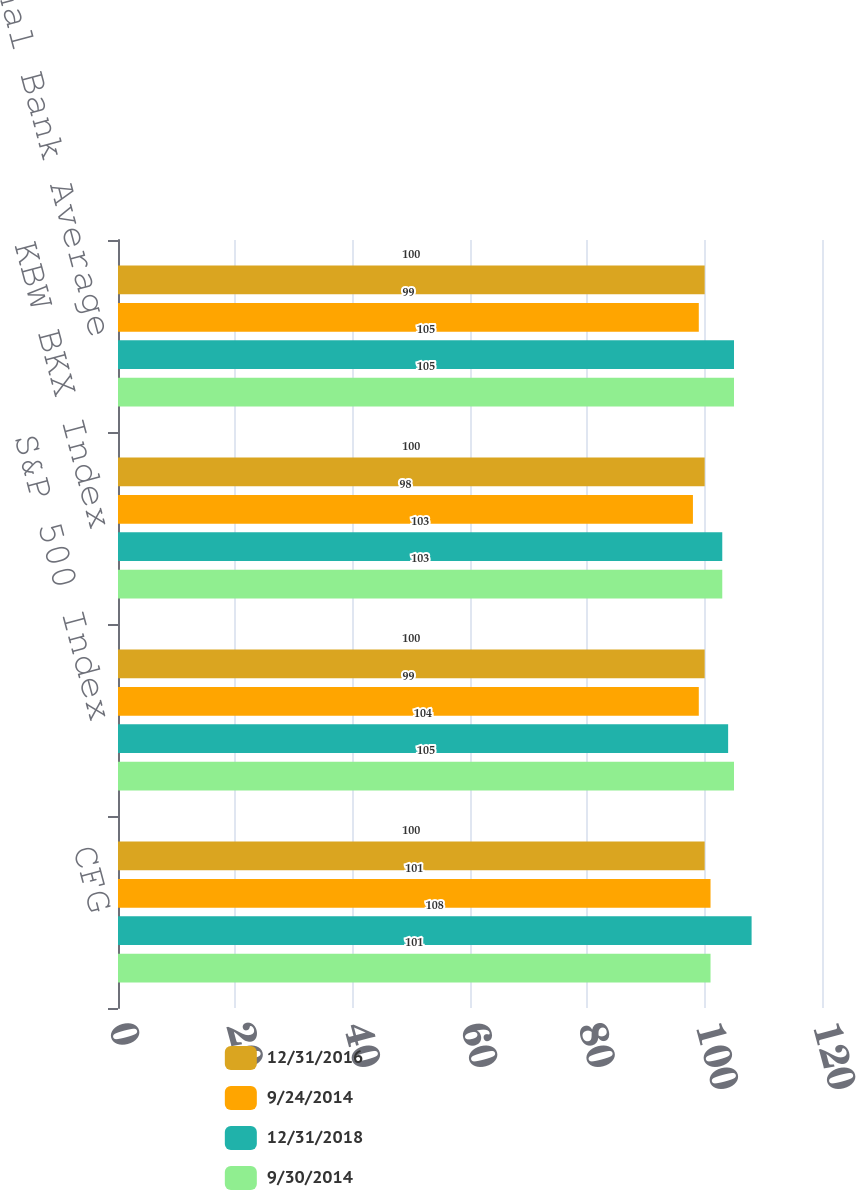<chart> <loc_0><loc_0><loc_500><loc_500><stacked_bar_chart><ecel><fcel>CFG<fcel>S&P 500 Index<fcel>KBW BKX Index<fcel>Peer Regional Bank Average<nl><fcel>12/31/2016<fcel>100<fcel>100<fcel>100<fcel>100<nl><fcel>9/24/2014<fcel>101<fcel>99<fcel>98<fcel>99<nl><fcel>12/31/2018<fcel>108<fcel>104<fcel>103<fcel>105<nl><fcel>9/30/2014<fcel>101<fcel>105<fcel>103<fcel>105<nl></chart> 